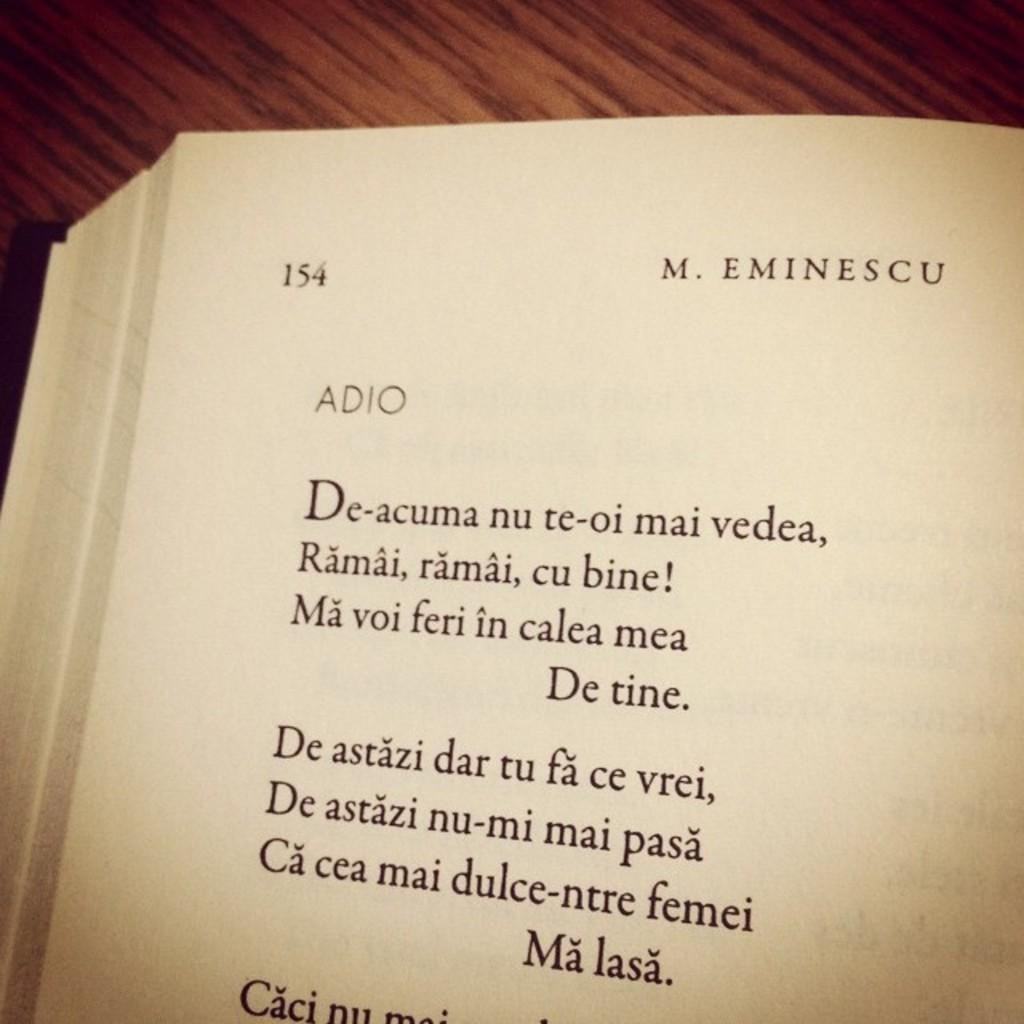<image>
Provide a brief description of the given image. A poem by M. Eminescu called Adio is featured in a book 